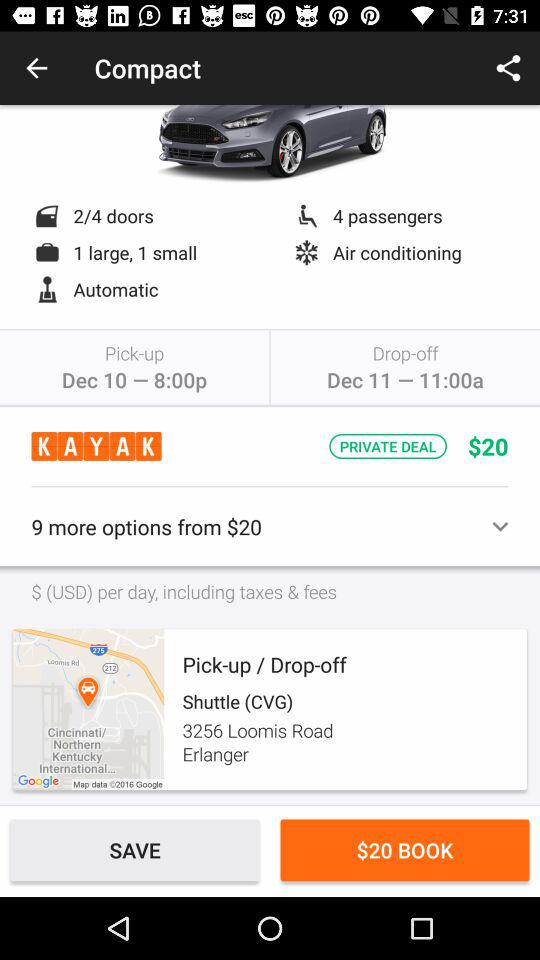What is the pick-up date and time? The pick-up date and time is December 10 at 8:00 pm. 